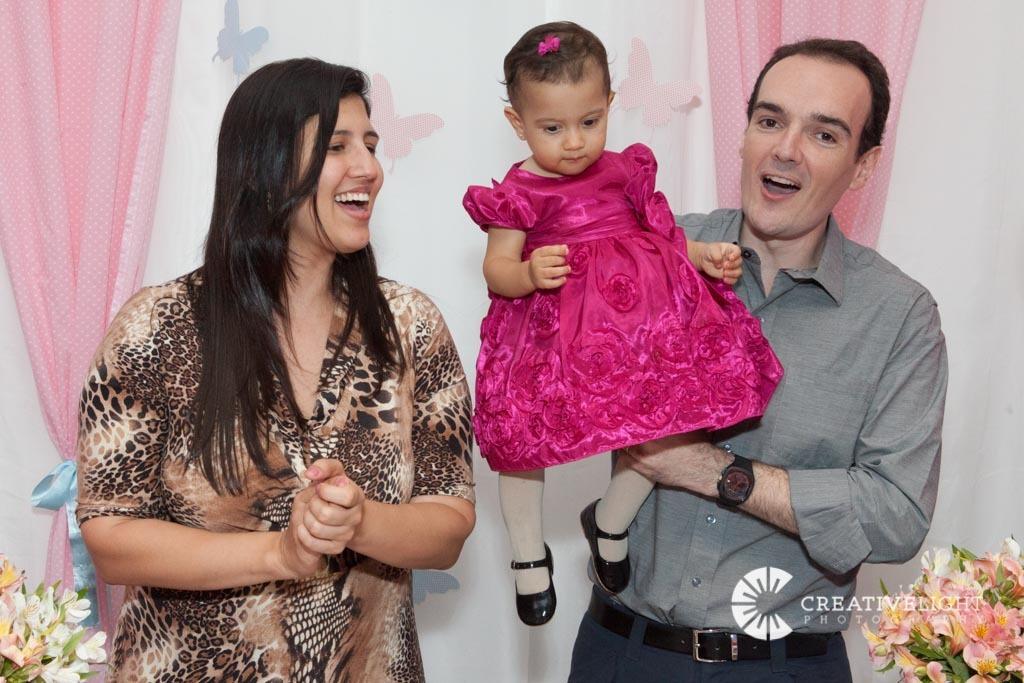Describe this image in one or two sentences. In this image we can see two people standing, one woman, one person holding a baby with pink gown, two flower pots with different flowers, two pink curtains and one white curtain with butterflies. 